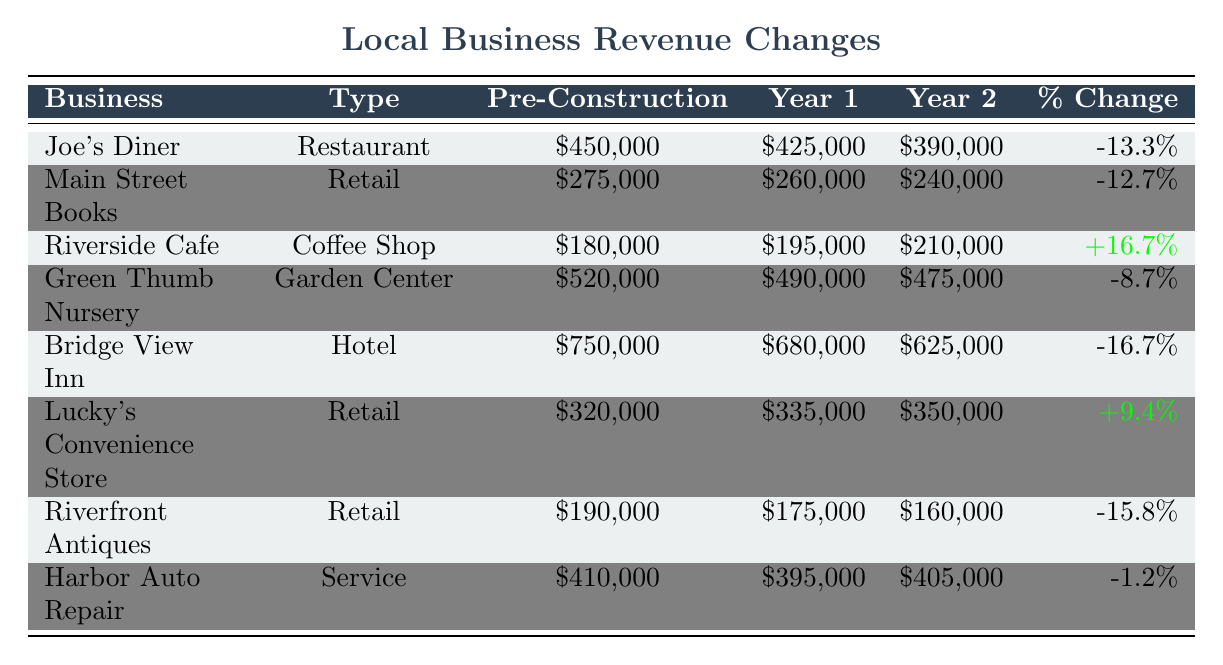What was the revenue of Joe's Diner in Year 1? According to the table, Joe's Diner had a revenue of $425,000 in Year 1.
Answer: $425,000 What was the percent change in revenue for Main Street Books? The table indicates that Main Street Books experienced a percent change of -12.7%.
Answer: -12.7% Which business saw an increase in revenue in Year 2 compared to Year 1? The table shows that Riverside Café's Year 2 revenue ($210,000) is greater than Year 1 ($195,000), indicating an increase.
Answer: Riverside Café What was the pre-construction revenue of Bridge View Inn? The pre-construction revenue for Bridge View Inn is listed as $750,000 in the table.
Answer: $750,000 Which type of business experienced the largest percent decrease in revenue? By reviewing the percent changes, Bridge View Inn had the largest decrease at -16.7%.
Answer: Hotel What was the total revenue for Lucky's Convenience Store in Year 1 and Year 2 combined? The total revenue for Lucky's Convenience Store is Year 1 ($335,000) plus Year 2 ($350,000), which equals $685,000.
Answer: $685,000 How did the revenue of Green Thumb Nursery change from Year 1 to Year 2? The table indicates a decrease in revenue from Year 1 ($490,000) to Year 2 ($475,000), showing a decline.
Answer: Decreased Which business's revenue remained relatively stable over the two years? Harbor Auto Repair's revenue changed only slightly from Year 1 ($395,000) to Year 2 ($405,000), showing stability.
Answer: Harbor Auto Repair What is the average revenue of the businesses listed in Year 2? To find the average, sum the Year 2 revenues ($390,000 + $240,000 + $210,000 + $475,000 + $625,000 + $350,000 + $160,000 + $405,000 = $2,670,000) and divide by the number of businesses (8), resulting in $333,750.
Answer: $333,750 Is it true that all businesses experienced a decrease in revenue after the bridge construction began? Not all businesses experienced a decrease; Riverside Café and Lucky's Convenience Store both saw an increase in their revenues.
Answer: No 